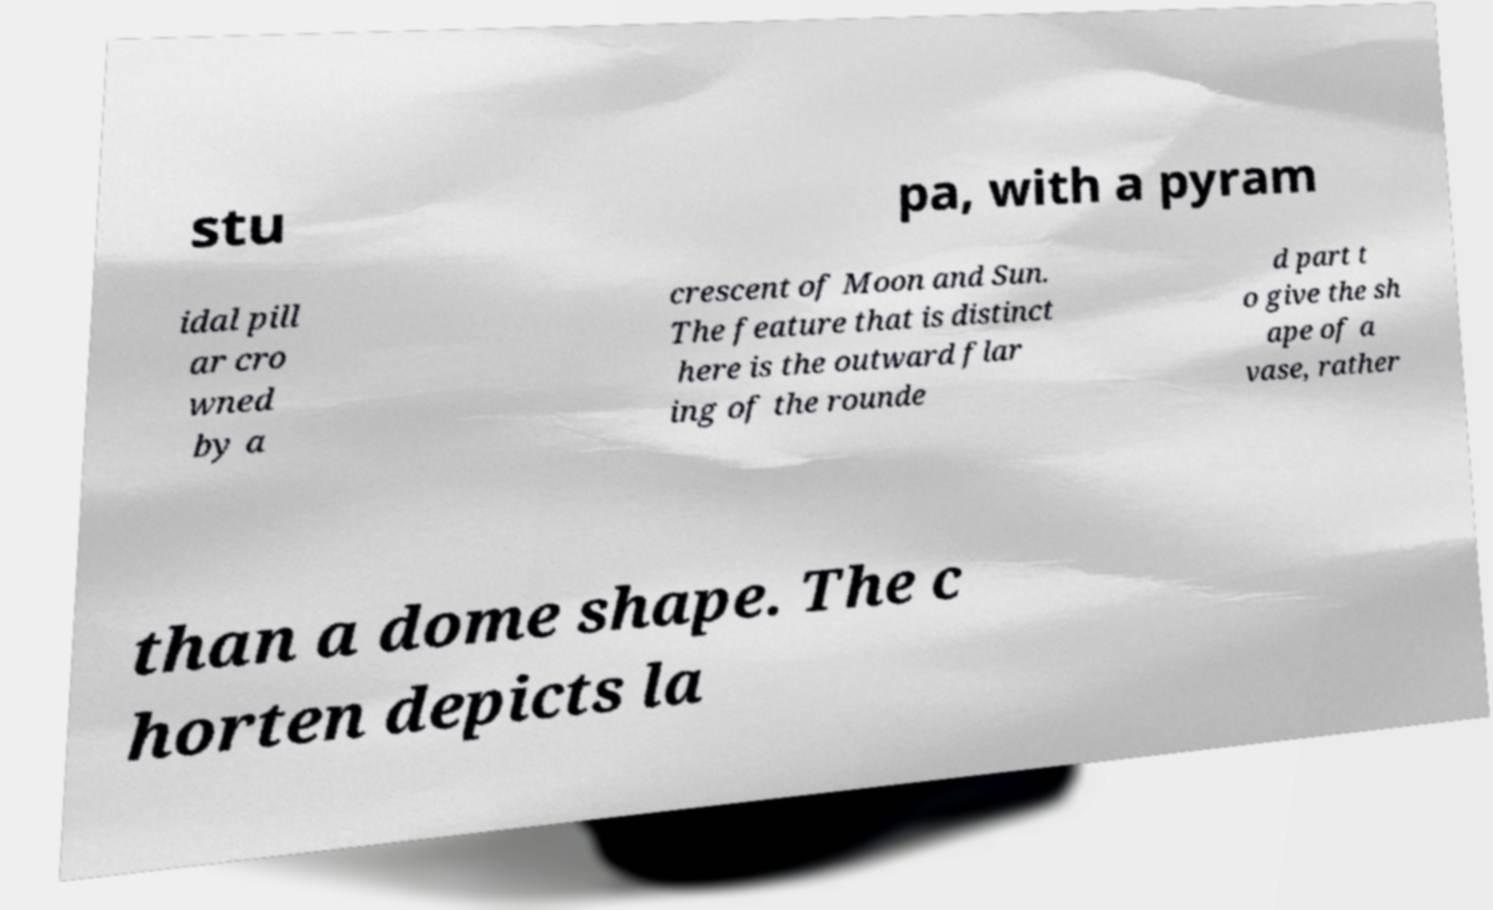Could you extract and type out the text from this image? stu pa, with a pyram idal pill ar cro wned by a crescent of Moon and Sun. The feature that is distinct here is the outward flar ing of the rounde d part t o give the sh ape of a vase, rather than a dome shape. The c horten depicts la 